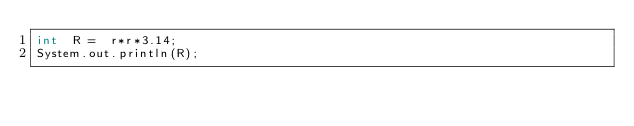<code> <loc_0><loc_0><loc_500><loc_500><_Java_>int  R =  r*r*3.14;
System.out.println(R);</code> 